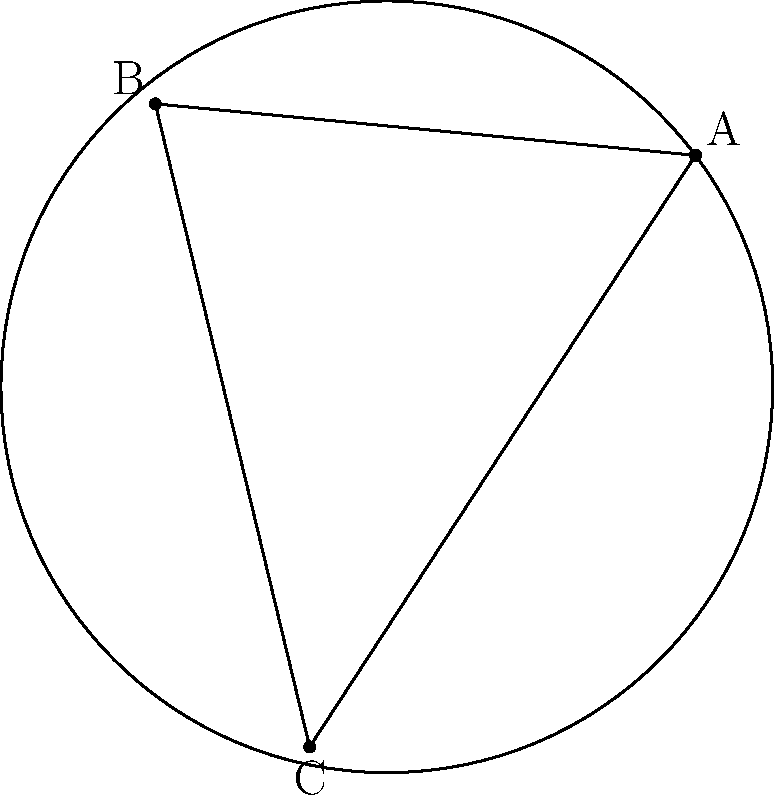In the elliptic geometry shown above, triangle ABC is drawn on the surface of a sphere. Given that the angles of the triangle are $\alpha = 70^\circ$, $\beta = 85^\circ$, and $\gamma = 100^\circ$, calculate the area of the triangle as a fraction of the total surface area of the sphere. Express your answer as a decimal rounded to three decimal places. To solve this problem, we'll follow these steps:

1) In elliptic geometry, the sum of the angles in a triangle is always greater than 180°. The excess over 180° is directly proportional to the area of the triangle.

2) Let's calculate the angle sum:
   $\alpha + \beta + \gamma = 70^\circ + 85^\circ + 100^\circ = 255^\circ$

3) The excess over 180° is:
   $255^\circ - 180^\circ = 75^\circ$

4) In elliptic geometry, the area of a triangle is given by the formula:
   $A = (\alpha + \beta + \gamma - \pi)R^2$
   where $R$ is the radius of the sphere.

5) The total surface area of a sphere is $4\pi R^2$.

6) The fraction of the sphere's surface area occupied by the triangle is:
   $\frac{A}{4\pi R^2} = \frac{(\alpha + \beta + \gamma - \pi)R^2}{4\pi R^2}$

7) Simplifying:
   $\frac{(\alpha + \beta + \gamma - \pi)}{4\pi}$

8) Converting 75° to radians:
   $75^\circ \times \frac{\pi}{180^\circ} = \frac{5\pi}{12}$

9) Substituting into our fraction:
   $\frac{\frac{5\pi}{12}}{4\pi} = \frac{5}{48} \approx 0.104$

Therefore, the triangle occupies approximately 0.104 or 10.4% of the sphere's surface area.
Answer: 0.104 